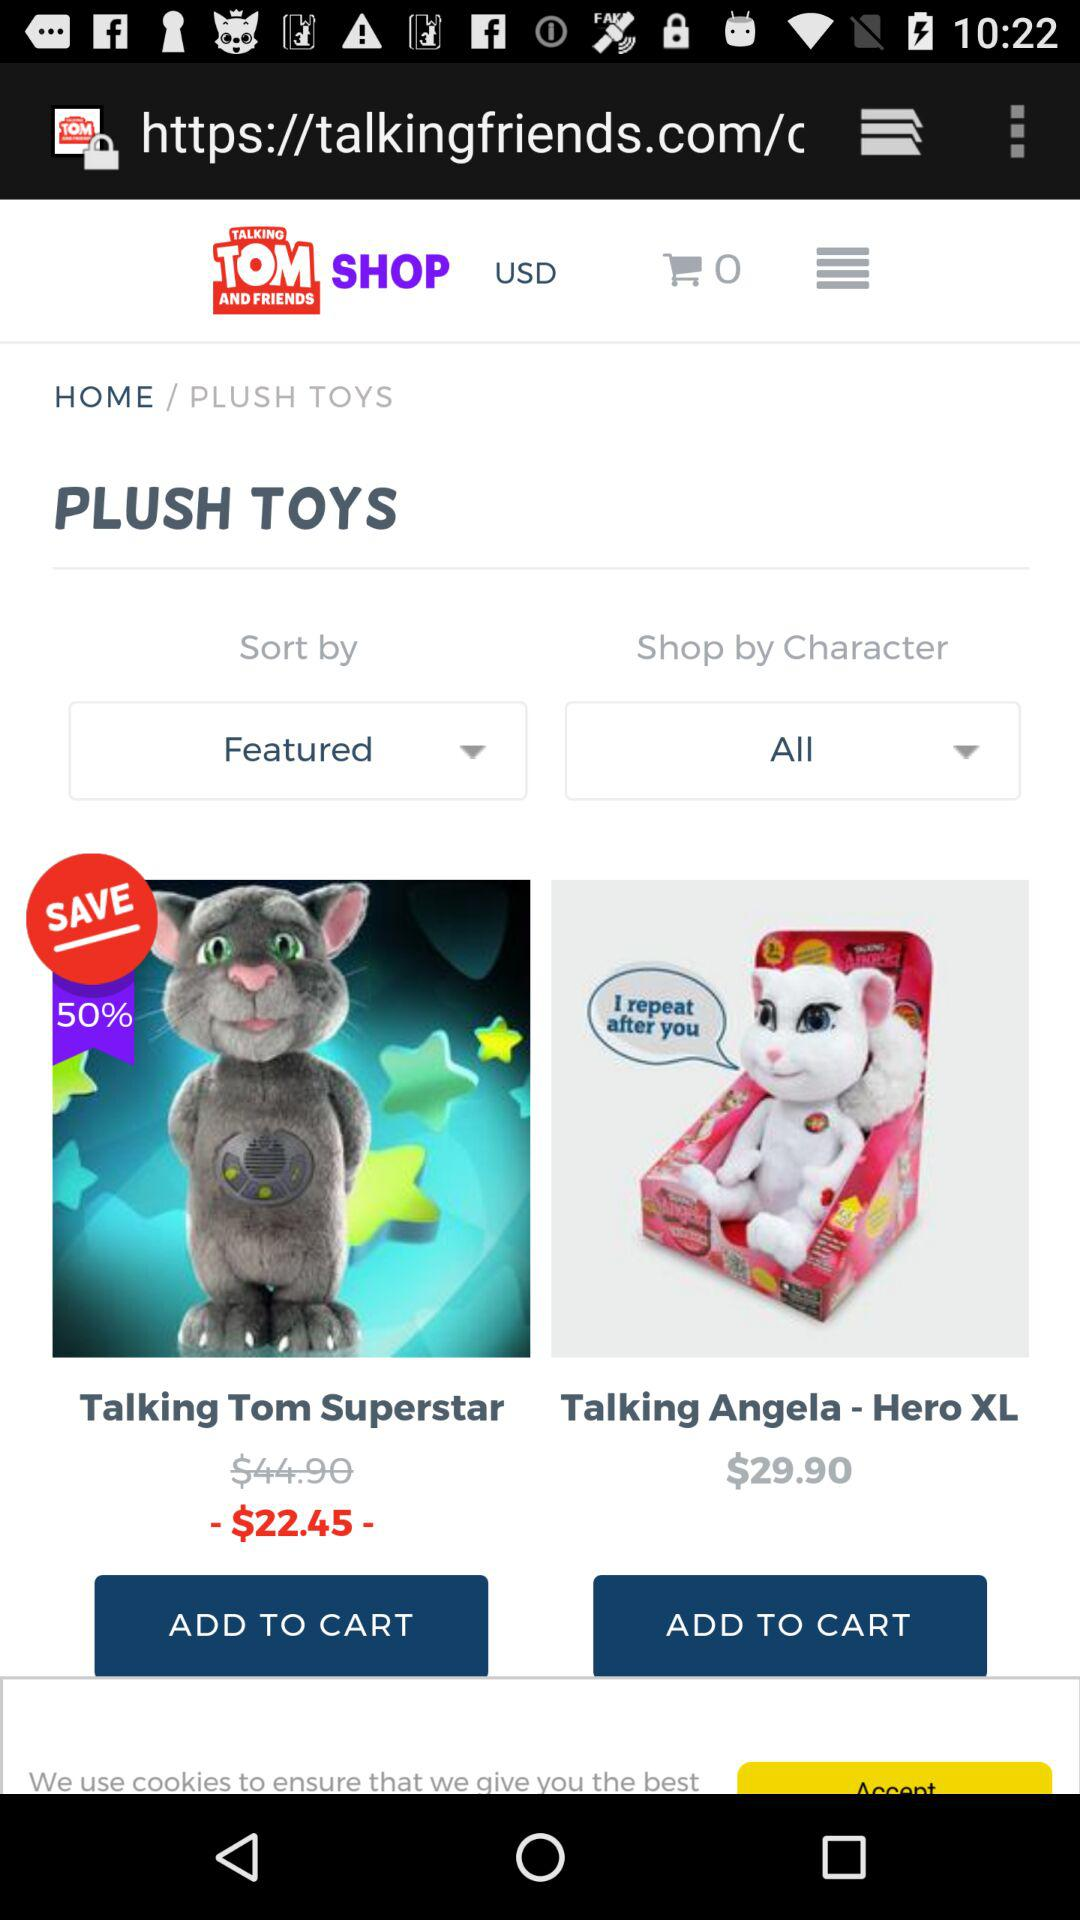What is the name of the application?
When the provided information is insufficient, respond with <no answer>. <no answer> 